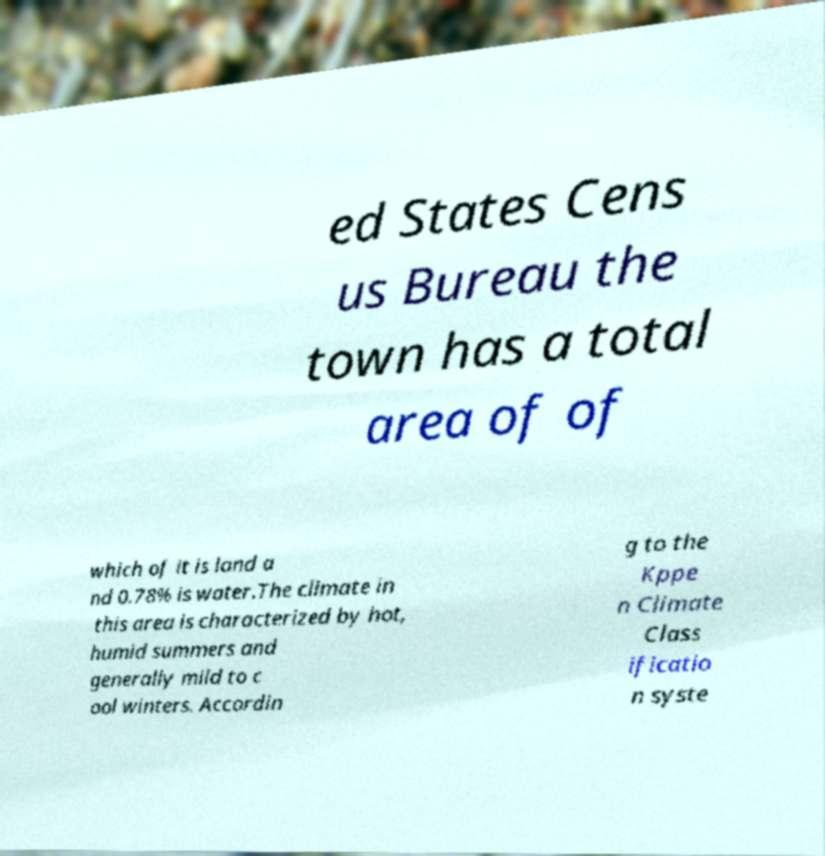Could you extract and type out the text from this image? ed States Cens us Bureau the town has a total area of of which of it is land a nd 0.78% is water.The climate in this area is characterized by hot, humid summers and generally mild to c ool winters. Accordin g to the Kppe n Climate Class ificatio n syste 